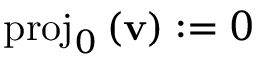<formula> <loc_0><loc_0><loc_500><loc_500>p r o j _ { 0 } \, ( v ) \colon = 0</formula> 